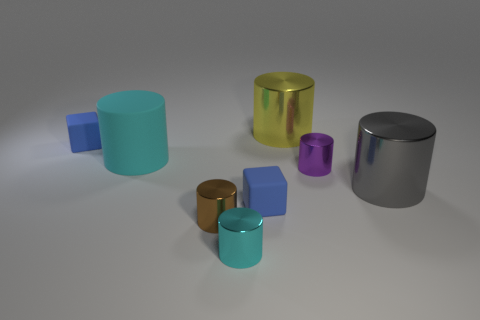How many matte cylinders are the same color as the large rubber object?
Make the answer very short. 0. There is a big shiny cylinder that is right of the yellow shiny thing; is its color the same as the large matte cylinder?
Provide a succinct answer. No. There is a big thing that is in front of the small purple thing; what shape is it?
Your response must be concise. Cylinder. There is a cube in front of the purple object; are there any metal things that are in front of it?
Keep it short and to the point. Yes. What number of big cylinders have the same material as the gray object?
Give a very brief answer. 1. There is a blue object that is left of the cyan object that is in front of the small blue matte thing to the right of the small cyan thing; how big is it?
Offer a terse response. Small. What number of big cylinders are in front of the matte cylinder?
Ensure brevity in your answer.  1. Is the number of metallic things greater than the number of tiny rubber cubes?
Provide a short and direct response. Yes. There is another object that is the same color as the big rubber object; what is its size?
Provide a short and direct response. Small. How big is the object that is behind the big cyan rubber cylinder and on the right side of the big rubber cylinder?
Provide a succinct answer. Large. 